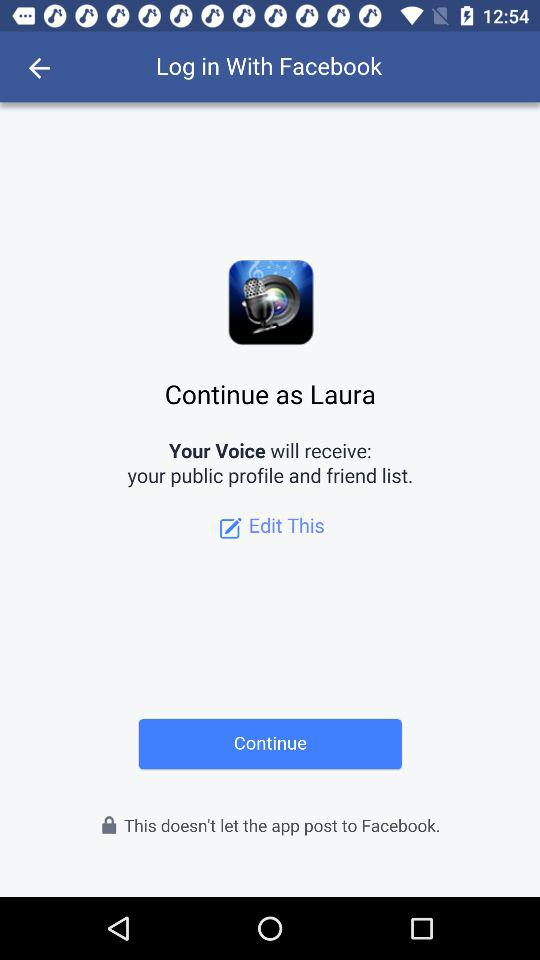What application can be used to log in? The application is "Facebook". 